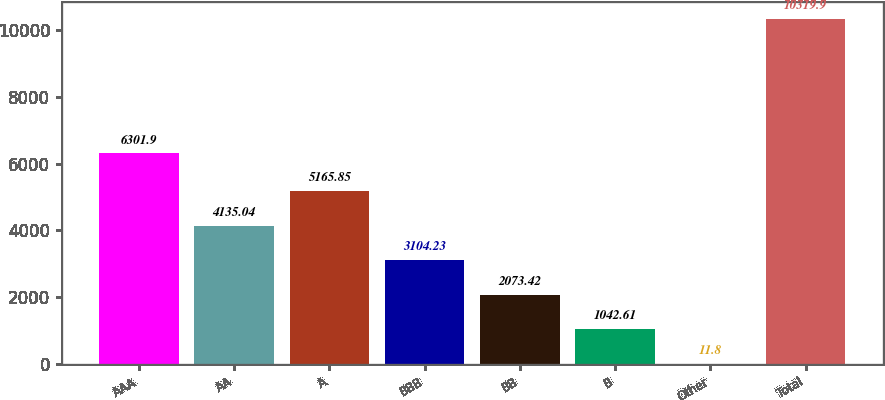<chart> <loc_0><loc_0><loc_500><loc_500><bar_chart><fcel>AAA<fcel>AA<fcel>A<fcel>BBB<fcel>BB<fcel>B<fcel>Other<fcel>Total<nl><fcel>6301.9<fcel>4135.04<fcel>5165.85<fcel>3104.23<fcel>2073.42<fcel>1042.61<fcel>11.8<fcel>10319.9<nl></chart> 